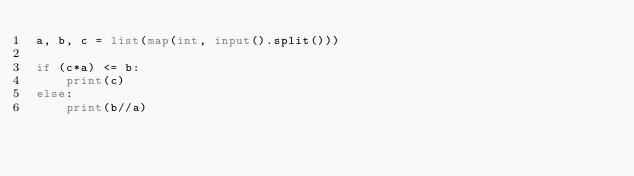<code> <loc_0><loc_0><loc_500><loc_500><_Python_>a, b, c = list(map(int, input().split()))

if (c*a) <= b:
    print(c)
else:
    print(b//a)</code> 